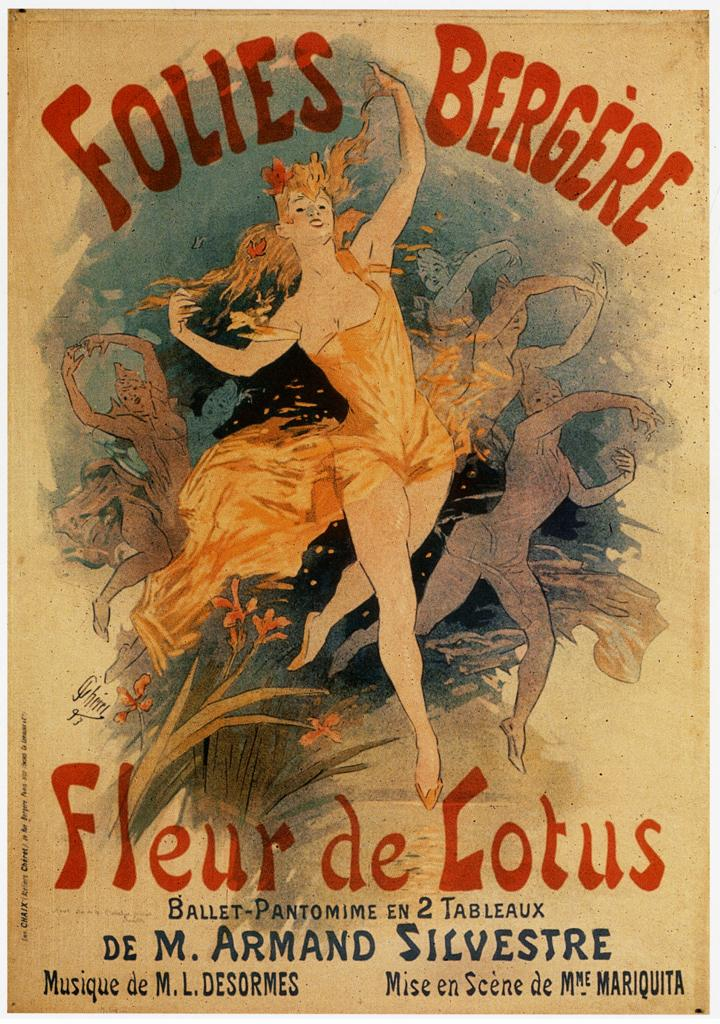<image>
Describe the image concisely. A ballerina is on a sign titled Folies Bergere. 